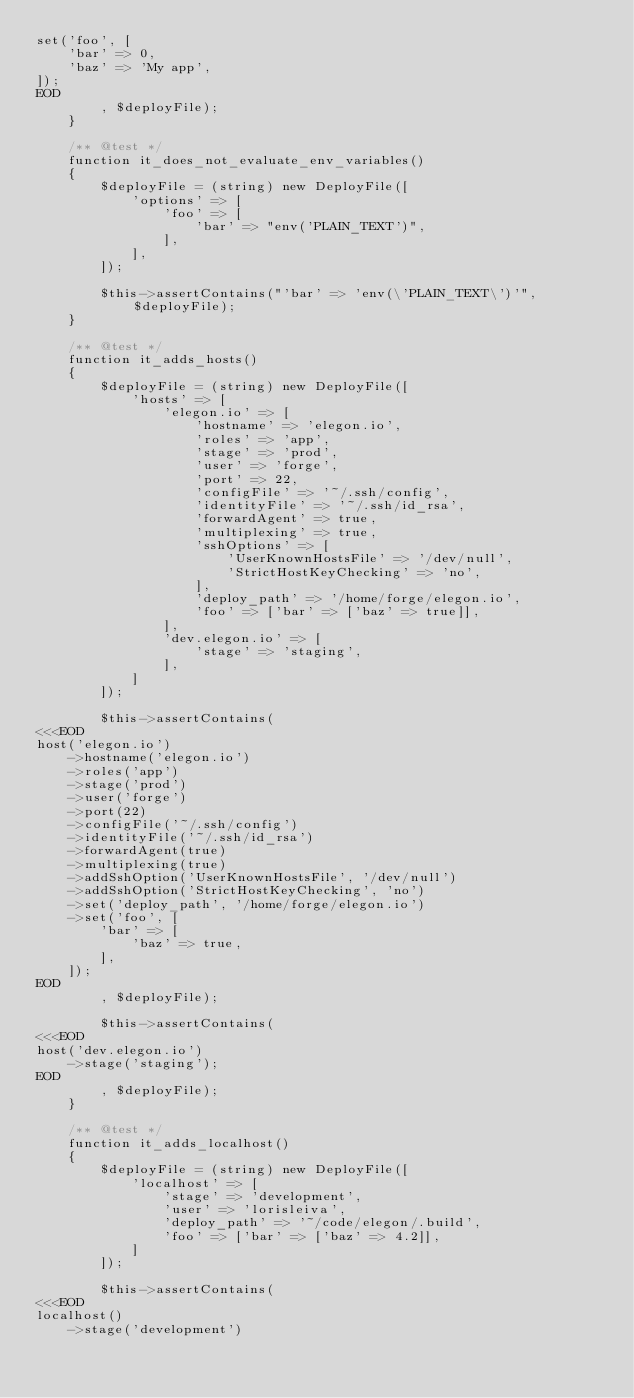<code> <loc_0><loc_0><loc_500><loc_500><_PHP_>set('foo', [
    'bar' => 0,
    'baz' => 'My app',
]);
EOD
        , $deployFile);
    }

    /** @test */
    function it_does_not_evaluate_env_variables()
    {
        $deployFile = (string) new DeployFile([
            'options' => [
                'foo' => [
                    'bar' => "env('PLAIN_TEXT')",
                ],
            ],
        ]);

        $this->assertContains("'bar' => 'env(\'PLAIN_TEXT\')'", $deployFile);
    }

    /** @test */
    function it_adds_hosts()
    {
        $deployFile = (string) new DeployFile([
            'hosts' => [
                'elegon.io' => [
                    'hostname' => 'elegon.io',
                    'roles' => 'app',
                    'stage' => 'prod',
                    'user' => 'forge',
                    'port' => 22,
                    'configFile' => '~/.ssh/config',
                    'identityFile' => '~/.ssh/id_rsa',
                    'forwardAgent' => true,
                    'multiplexing' => true,
                    'sshOptions' => [
                        'UserKnownHostsFile' => '/dev/null',
                        'StrictHostKeyChecking' => 'no',
                    ],
                    'deploy_path' => '/home/forge/elegon.io',
                    'foo' => ['bar' => ['baz' => true]],
                ],
                'dev.elegon.io' => [
                    'stage' => 'staging',
                ],
            ]
        ]);

        $this->assertContains(
<<<EOD
host('elegon.io')
    ->hostname('elegon.io')
    ->roles('app')
    ->stage('prod')
    ->user('forge')
    ->port(22)
    ->configFile('~/.ssh/config')
    ->identityFile('~/.ssh/id_rsa')
    ->forwardAgent(true)
    ->multiplexing(true)
    ->addSshOption('UserKnownHostsFile', '/dev/null')
    ->addSshOption('StrictHostKeyChecking', 'no')
    ->set('deploy_path', '/home/forge/elegon.io')
    ->set('foo', [
        'bar' => [
            'baz' => true,
        ],
    ]);
EOD
        , $deployFile);

        $this->assertContains(
<<<EOD
host('dev.elegon.io')
    ->stage('staging');
EOD
        , $deployFile);
    }

    /** @test */
    function it_adds_localhost()
    {
        $deployFile = (string) new DeployFile([
            'localhost' => [
                'stage' => 'development',
                'user' => 'lorisleiva',
                'deploy_path' => '~/code/elegon/.build',
                'foo' => ['bar' => ['baz' => 4.2]],
            ]
        ]);

        $this->assertContains(
<<<EOD
localhost()
    ->stage('development')</code> 